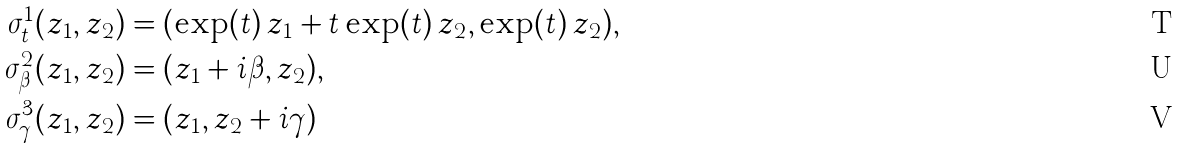<formula> <loc_0><loc_0><loc_500><loc_500>\sigma ^ { 1 } _ { t } ( z _ { 1 } , z _ { 2 } ) & = ( \exp ( t ) \, z _ { 1 } + t \exp ( t ) \, z _ { 2 } , \exp ( t ) \, z _ { 2 } ) , \\ \sigma ^ { 2 } _ { \beta } ( z _ { 1 } , z _ { 2 } ) & = ( z _ { 1 } + i \beta , z _ { 2 } ) , \\ \sigma ^ { 3 } _ { \gamma } ( z _ { 1 } , z _ { 2 } ) & = ( z _ { 1 } , z _ { 2 } + i \gamma )</formula> 